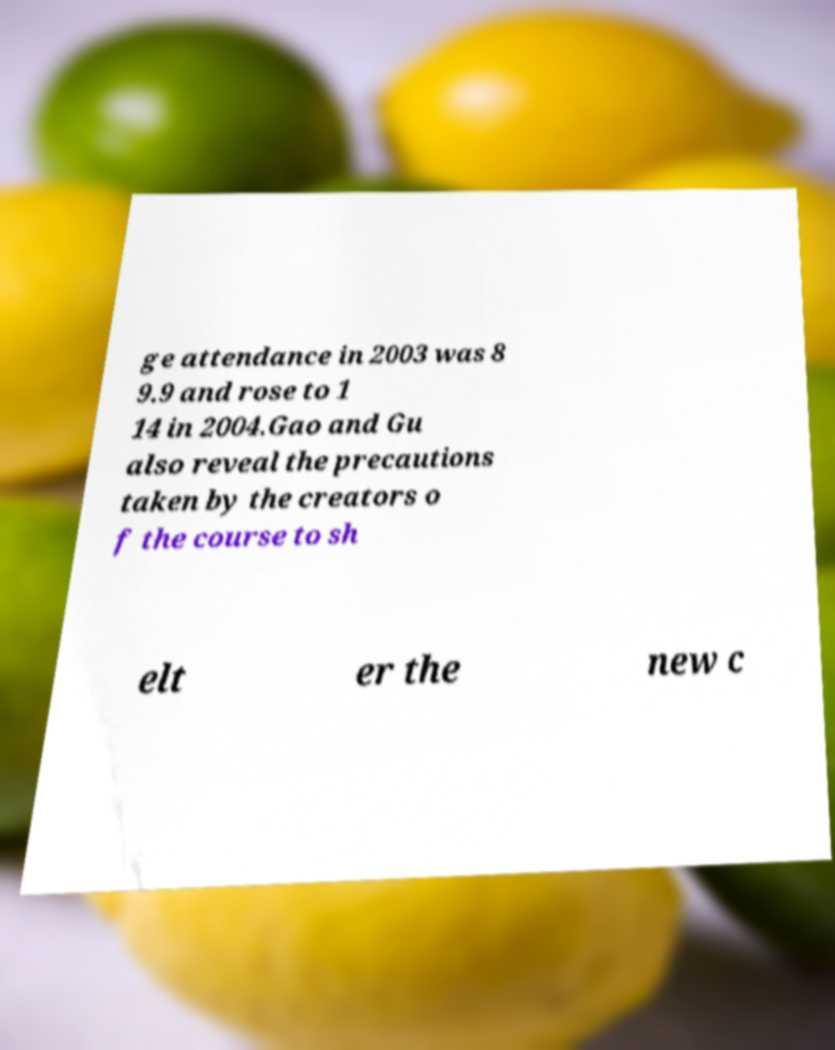For documentation purposes, I need the text within this image transcribed. Could you provide that? ge attendance in 2003 was 8 9.9 and rose to 1 14 in 2004.Gao and Gu also reveal the precautions taken by the creators o f the course to sh elt er the new c 